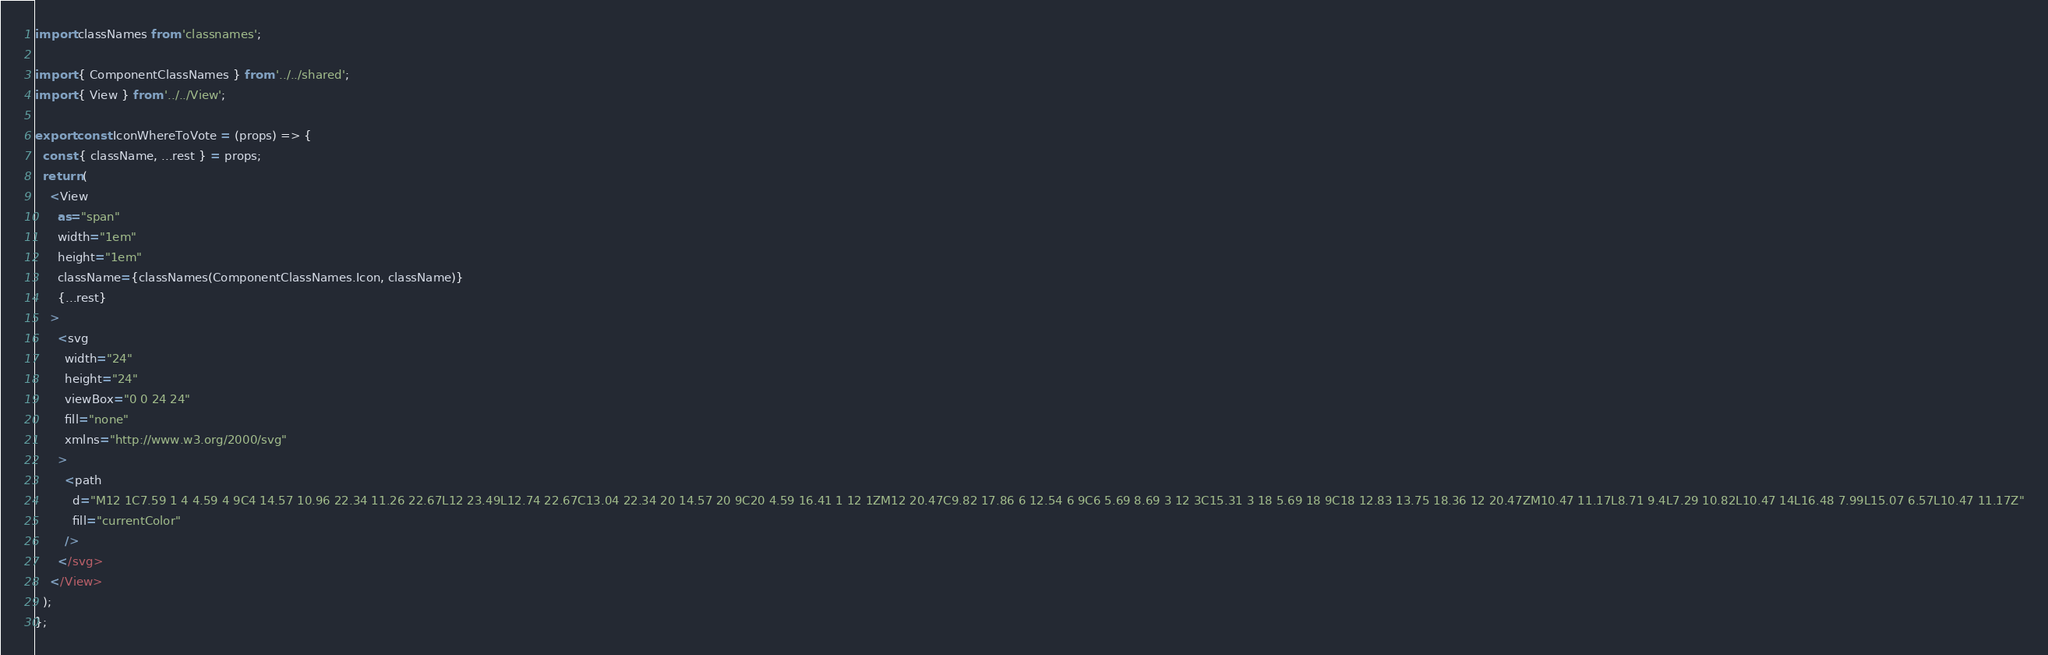Convert code to text. <code><loc_0><loc_0><loc_500><loc_500><_TypeScript_>import classNames from 'classnames';

import { ComponentClassNames } from '../../shared';
import { View } from '../../View';

export const IconWhereToVote = (props) => {
  const { className, ...rest } = props;
  return (
    <View
      as="span"
      width="1em"
      height="1em"
      className={classNames(ComponentClassNames.Icon, className)}
      {...rest}
    >
      <svg
        width="24"
        height="24"
        viewBox="0 0 24 24"
        fill="none"
        xmlns="http://www.w3.org/2000/svg"
      >
        <path
          d="M12 1C7.59 1 4 4.59 4 9C4 14.57 10.96 22.34 11.26 22.67L12 23.49L12.74 22.67C13.04 22.34 20 14.57 20 9C20 4.59 16.41 1 12 1ZM12 20.47C9.82 17.86 6 12.54 6 9C6 5.69 8.69 3 12 3C15.31 3 18 5.69 18 9C18 12.83 13.75 18.36 12 20.47ZM10.47 11.17L8.71 9.4L7.29 10.82L10.47 14L16.48 7.99L15.07 6.57L10.47 11.17Z"
          fill="currentColor"
        />
      </svg>
    </View>
  );
};
</code> 